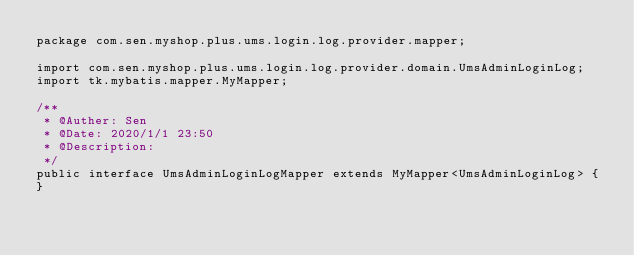<code> <loc_0><loc_0><loc_500><loc_500><_Java_>package com.sen.myshop.plus.ums.login.log.provider.mapper;

import com.sen.myshop.plus.ums.login.log.provider.domain.UmsAdminLoginLog;
import tk.mybatis.mapper.MyMapper;

/**
 * @Auther: Sen
 * @Date: 2020/1/1 23:50
 * @Description: 
 */
public interface UmsAdminLoginLogMapper extends MyMapper<UmsAdminLoginLog> {
}</code> 